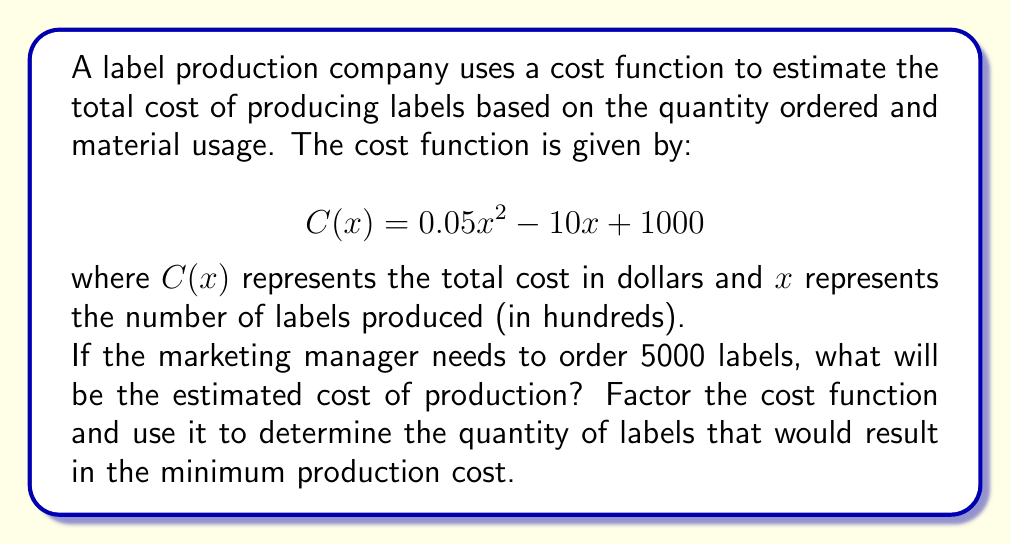Can you answer this question? To solve this problem, we'll follow these steps:

1. Calculate the cost for 5000 labels
2. Factor the cost function
3. Determine the quantity for minimum cost

Step 1: Calculate the cost for 5000 labels
- 5000 labels = 50 hundreds of labels
- Substitute $x = 50$ into the cost function:

$$\begin{align}
C(50) &= 0.05(50)^2 - 10(50) + 1000 \\
&= 0.05(2500) - 500 + 1000 \\
&= 125 - 500 + 1000 \\
&= 625
\end{align}$$

Step 2: Factor the cost function
The cost function is a quadratic equation in the form $ax^2 + bx + c$:

$$C(x) = 0.05x^2 - 10x + 1000$$

To factor this, we'll use the quadratic formula: $x = \frac{-b \pm \sqrt{b^2 - 4ac}}{2a}$

$$\begin{align}
a &= 0.05 \\
b &= -10 \\
c &= 1000
\end{align}$$

Substituting these values:

$$\begin{align}
x &= \frac{10 \pm \sqrt{(-10)^2 - 4(0.05)(1000)}}{2(0.05)} \\
&= \frac{10 \pm \sqrt{100 - 200}}{0.1} \\
&= \frac{10 \pm \sqrt{-100}}{0.1}
\end{align}$$

Since the discriminant is negative, there are no real roots. However, we can factor out the coefficient of $x^2$:

$$C(x) = 0.05(x^2 - 200x + 20000)$$

Step 3: Determine the quantity for minimum cost
For a quadratic function $ax^2 + bx + c$, the x-coordinate of the vertex (which gives the minimum or maximum point) is given by $x = -\frac{b}{2a}$.

In our factored form, $0.05(x^2 - 200x + 20000)$, we have:

$$\begin{align}
a &= 0.05 \\
b &= -200(0.05) = -10
\end{align}$$

Therefore, the x-coordinate of the vertex is:

$$x = -\frac{-10}{2(0.05)} = \frac{10}{0.1} = 100$$

This means the minimum cost occurs when producing 100 hundreds of labels, or 10,000 labels.
Answer: The estimated cost of producing 5000 labels is $625. The factored cost function is $C(x) = 0.05(x^2 - 200x + 20000)$. The quantity that results in the minimum production cost is 10,000 labels. 